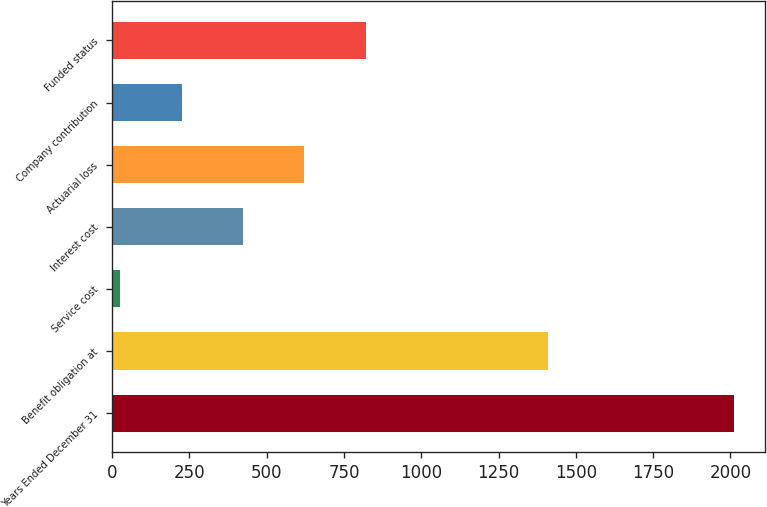Convert chart to OTSL. <chart><loc_0><loc_0><loc_500><loc_500><bar_chart><fcel>Years Ended December 31<fcel>Benefit obligation at<fcel>Service cost<fcel>Interest cost<fcel>Actuarial loss<fcel>Company contribution<fcel>Funded status<nl><fcel>2011<fcel>1410<fcel>27<fcel>423.8<fcel>622.2<fcel>225.4<fcel>820.6<nl></chart> 